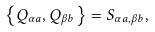<formula> <loc_0><loc_0><loc_500><loc_500>\left \{ Q _ { \alpha a } , Q _ { \beta b } \right \} = S _ { \alpha a , \beta b } ,</formula> 